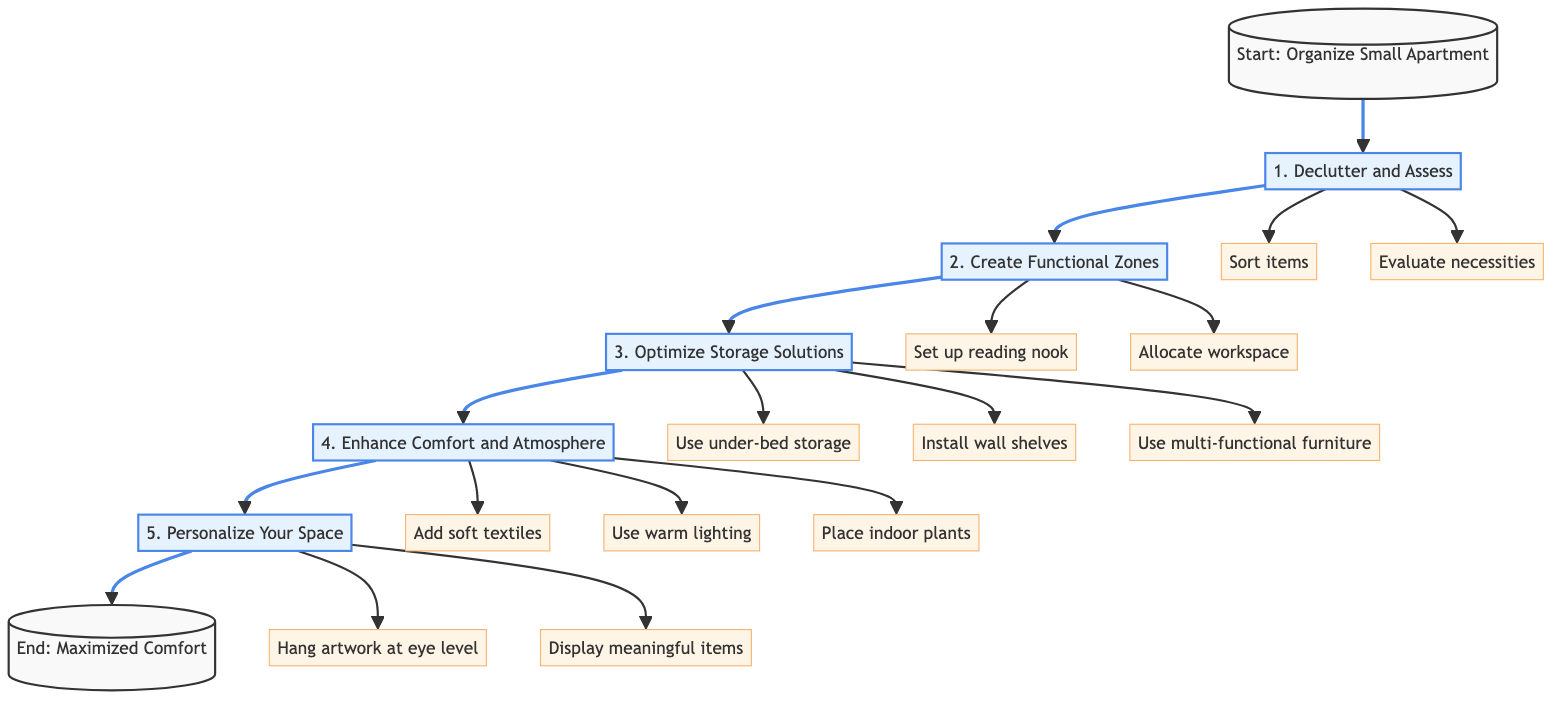What is the first step in organizing a small apartment? The flowchart indicates that the first step is labeled "1. Declutter and Assess." This is the initial point in the process of organizing.
Answer: 1. Declutter and Assess How many main steps are outlined in the diagram? By counting the numbered steps from the diagram, we find there are five main steps provided in the instruction sequence.
Answer: 5 What is the last step to achieve maximum comfort? The flowchart shows that the last step listed is "5. Personalize Your Space," which concludes the instructions for maximizing comfort in the apartment.
Answer: 5. Personalize Your Space What should you do after creating functional zones? The next step after "Create Functional Zones" is "3. Optimize Storage Solutions," which follows in the flow of the instruction process.
Answer: 3. Optimize Storage Solutions How many detailed actions are suggested for optimizing storage solutions? The diagram provides three detailed actions under the "Optimize Storage Solutions" step, each aimed at improving storage options in the apartment.
Answer: 3 